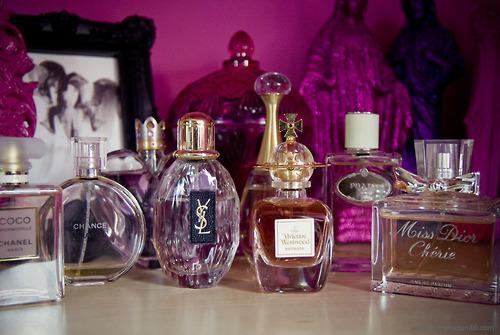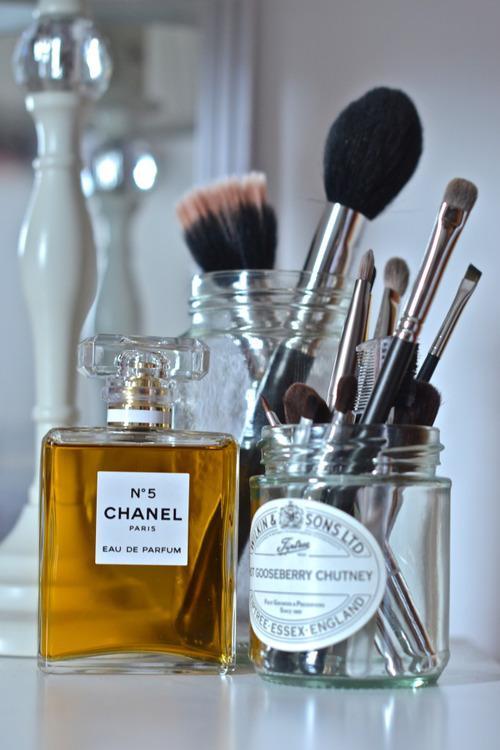The first image is the image on the left, the second image is the image on the right. Assess this claim about the two images: "The left image shows a collection of fragrance bottles on a tray, and the leftmost bottle in the front row has a round black cap.". Correct or not? Answer yes or no. No. 